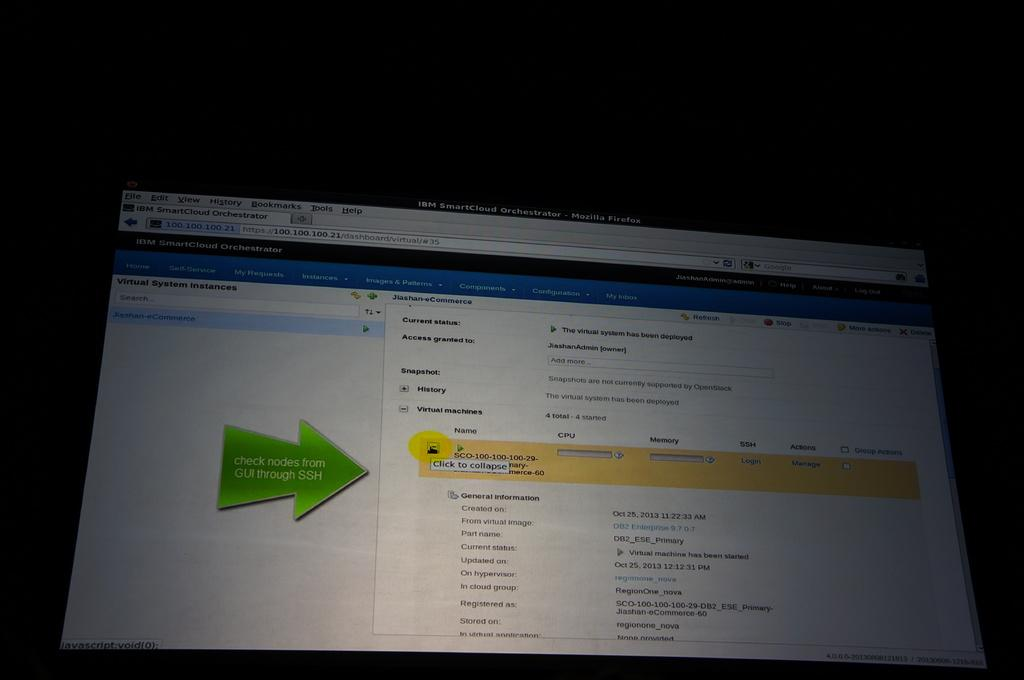Provide a one-sentence caption for the provided image. A screen with a green arrow that says "Check Nodes from GUI through SSH" on it. 